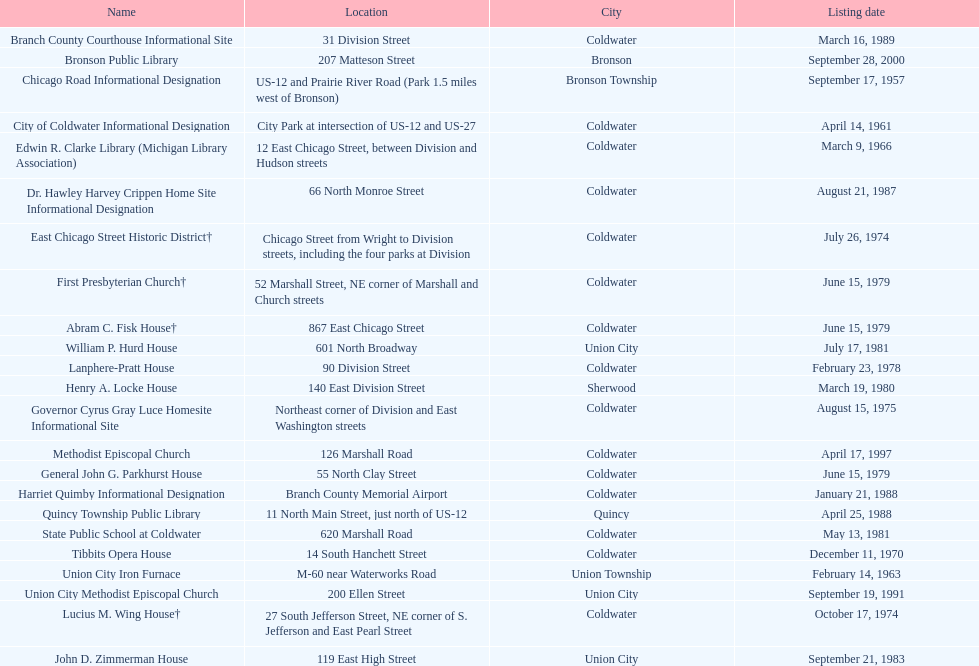What is the overall number of names currently listed on this chart? 23. 